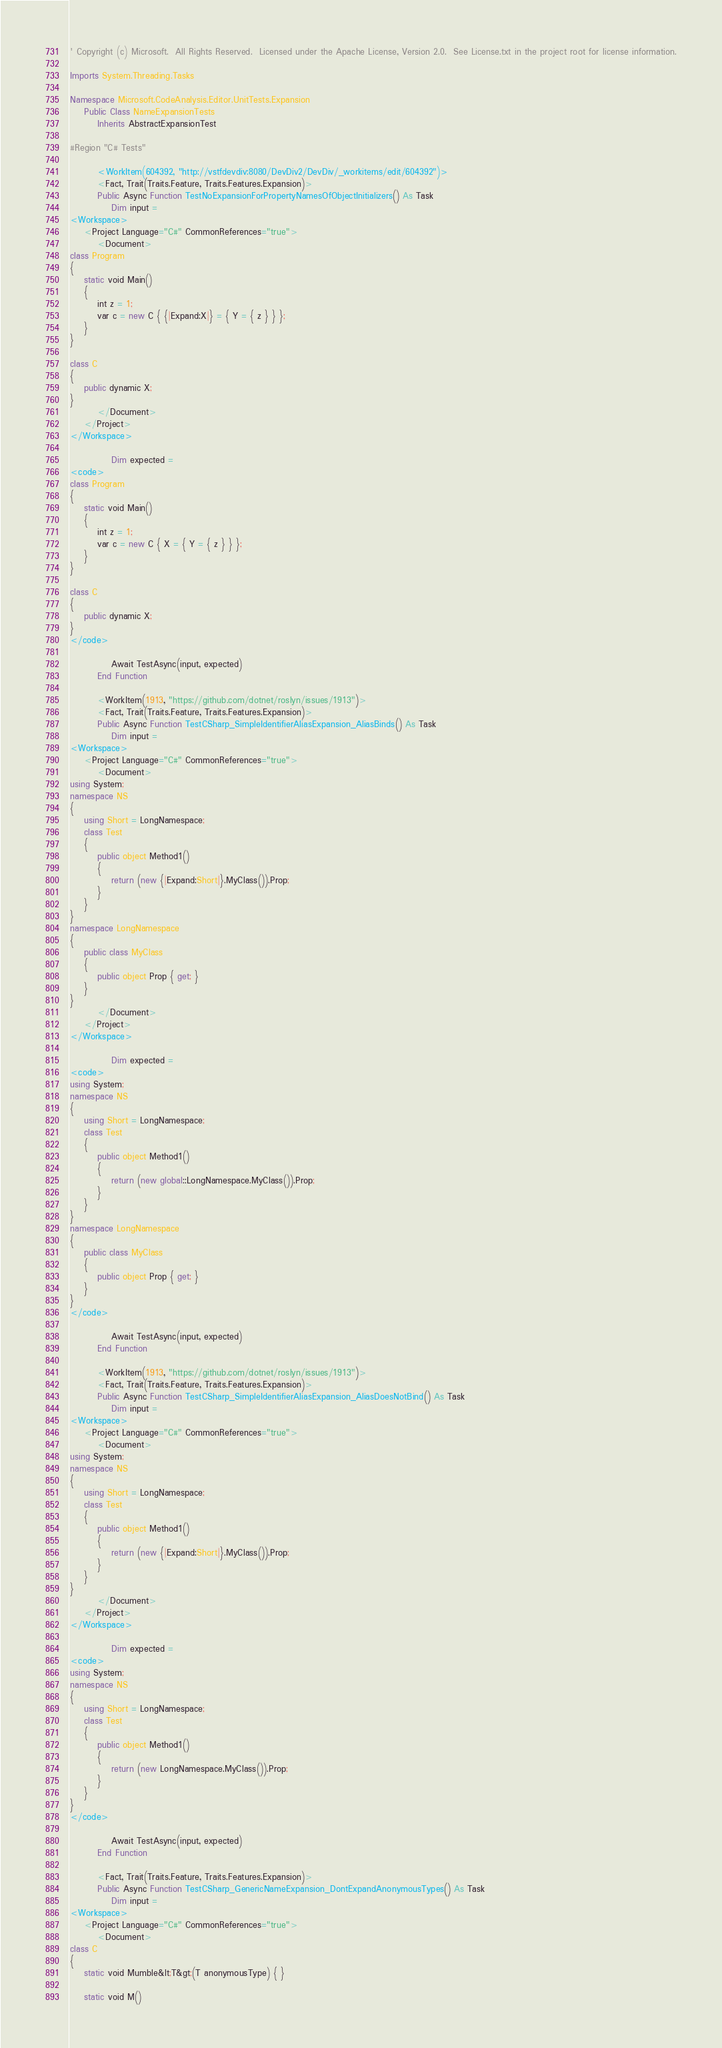Convert code to text. <code><loc_0><loc_0><loc_500><loc_500><_VisualBasic_>' Copyright (c) Microsoft.  All Rights Reserved.  Licensed under the Apache License, Version 2.0.  See License.txt in the project root for license information.

Imports System.Threading.Tasks

Namespace Microsoft.CodeAnalysis.Editor.UnitTests.Expansion
    Public Class NameExpansionTests
        Inherits AbstractExpansionTest

#Region "C# Tests"

        <WorkItem(604392, "http://vstfdevdiv:8080/DevDiv2/DevDiv/_workitems/edit/604392")>
        <Fact, Trait(Traits.Feature, Traits.Features.Expansion)>
        Public Async Function TestNoExpansionForPropertyNamesOfObjectInitializers() As Task
            Dim input =
<Workspace>
    <Project Language="C#" CommonReferences="true">
        <Document>
class Program
{
    static void Main()
    {
        int z = 1;
        var c = new C { {|Expand:X|} = { Y = { z } } };
    }
}
 
class C
{
    public dynamic X;
}
        </Document>
    </Project>
</Workspace>

            Dim expected =
<code>
class Program
{
    static void Main()
    {
        int z = 1;
        var c = new C { X = { Y = { z } } };
    }
}

class C
{
    public dynamic X;
}
</code>

            Await TestAsync(input, expected)
        End Function

        <WorkItem(1913, "https://github.com/dotnet/roslyn/issues/1913")>
        <Fact, Trait(Traits.Feature, Traits.Features.Expansion)>
        Public Async Function TestCSharp_SimpleIdentifierAliasExpansion_AliasBinds() As Task
            Dim input =
<Workspace>
    <Project Language="C#" CommonReferences="true">
        <Document>
using System;
namespace NS
{
    using Short = LongNamespace;
    class Test
    {
        public object Method1()
        {
            return (new {|Expand:Short|}.MyClass()).Prop;
        }
    }
}
namespace LongNamespace
{
    public class MyClass
    {
        public object Prop { get; }
    }
}
        </Document>
    </Project>
</Workspace>

            Dim expected =
<code>
using System;
namespace NS
{
    using Short = LongNamespace;
    class Test
    {
        public object Method1()
        {
            return (new global::LongNamespace.MyClass()).Prop;
        }
    }
}
namespace LongNamespace
{
    public class MyClass
    {
        public object Prop { get; }
    }
}
</code>

            Await TestAsync(input, expected)
        End Function

        <WorkItem(1913, "https://github.com/dotnet/roslyn/issues/1913")>
        <Fact, Trait(Traits.Feature, Traits.Features.Expansion)>
        Public Async Function TestCSharp_SimpleIdentifierAliasExpansion_AliasDoesNotBind() As Task
            Dim input =
<Workspace>
    <Project Language="C#" CommonReferences="true">
        <Document>
using System;
namespace NS
{
    using Short = LongNamespace;
    class Test
    {
        public object Method1()
        {
            return (new {|Expand:Short|}.MyClass()).Prop;
        }
    }
}
        </Document>
    </Project>
</Workspace>

            Dim expected =
<code>
using System;
namespace NS
{
    using Short = LongNamespace;
    class Test
    {
        public object Method1()
        {
            return (new LongNamespace.MyClass()).Prop;
        }
    }
}
</code>

            Await TestAsync(input, expected)
        End Function

        <Fact, Trait(Traits.Feature, Traits.Features.Expansion)>
        Public Async Function TestCSharp_GenericNameExpansion_DontExpandAnonymousTypes() As Task
            Dim input =
<Workspace>
    <Project Language="C#" CommonReferences="true">
        <Document>
class C
{
    static void Mumble&lt;T&gt;(T anonymousType) { }

    static void M()</code> 